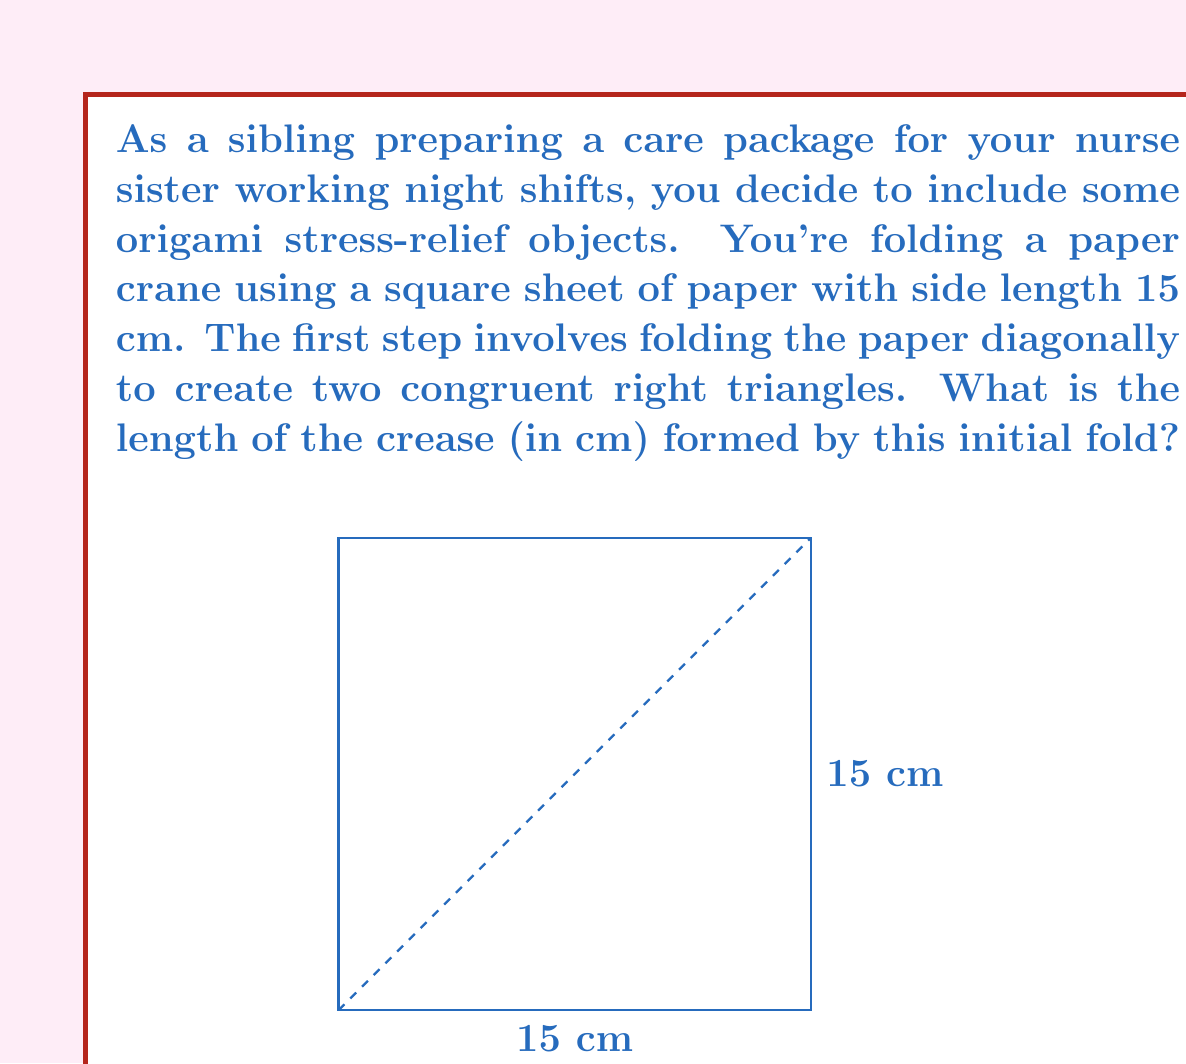Provide a solution to this math problem. Let's approach this step-by-step:

1) The paper is a square with side length 15 cm.

2) When folded diagonally, it forms two congruent right triangles.

3) The crease is the diagonal of the square, which forms the hypotenuse of each right triangle.

4) To find the length of the diagonal, we can use the Pythagorean theorem:

   $$a^2 + b^2 = c^2$$

   where $a$ and $b$ are the sides of the right triangle (which are the sides of the square), and $c$ is the hypotenuse (the diagonal we're looking for).

5) Substituting the known values:

   $$15^2 + 15^2 = c^2$$

6) Simplify:

   $$225 + 225 = c^2$$
   $$450 = c^2$$

7) Take the square root of both sides:

   $$\sqrt{450} = c$$

8) Simplify the square root:

   $$\sqrt{450} = \sqrt{2} \cdot \sqrt{225} = 15\sqrt{2}$$

Therefore, the length of the diagonal (the crease) is $15\sqrt{2}$ cm.
Answer: $15\sqrt{2}$ cm 